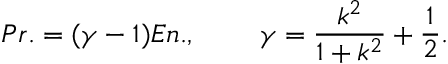<formula> <loc_0><loc_0><loc_500><loc_500>P r . = ( \gamma - 1 ) E n . , \, \gamma = \frac { k ^ { 2 } } { 1 + k ^ { 2 } } + \frac { 1 } { 2 } .</formula> 